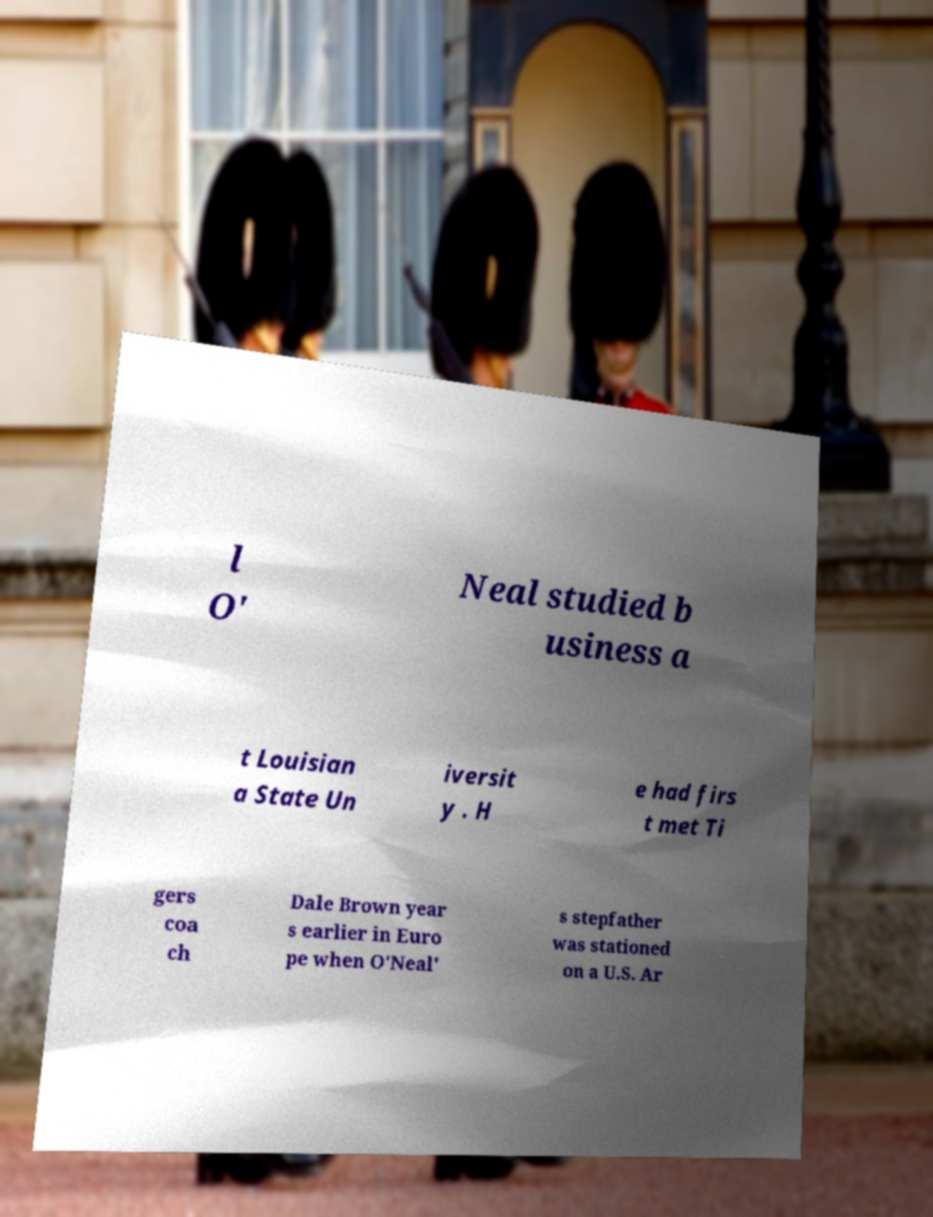Can you accurately transcribe the text from the provided image for me? l O' Neal studied b usiness a t Louisian a State Un iversit y . H e had firs t met Ti gers coa ch Dale Brown year s earlier in Euro pe when O'Neal' s stepfather was stationed on a U.S. Ar 